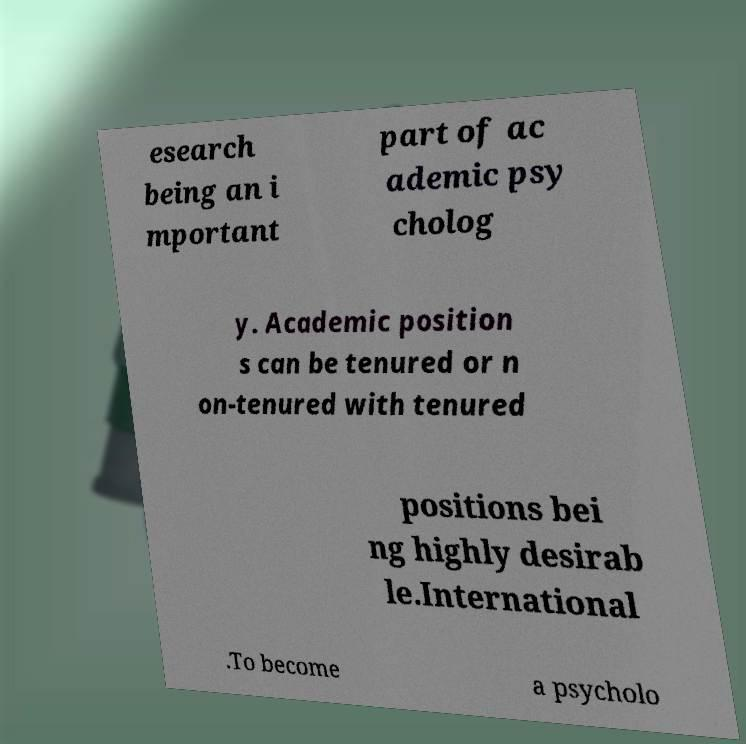I need the written content from this picture converted into text. Can you do that? esearch being an i mportant part of ac ademic psy cholog y. Academic position s can be tenured or n on-tenured with tenured positions bei ng highly desirab le.International .To become a psycholo 